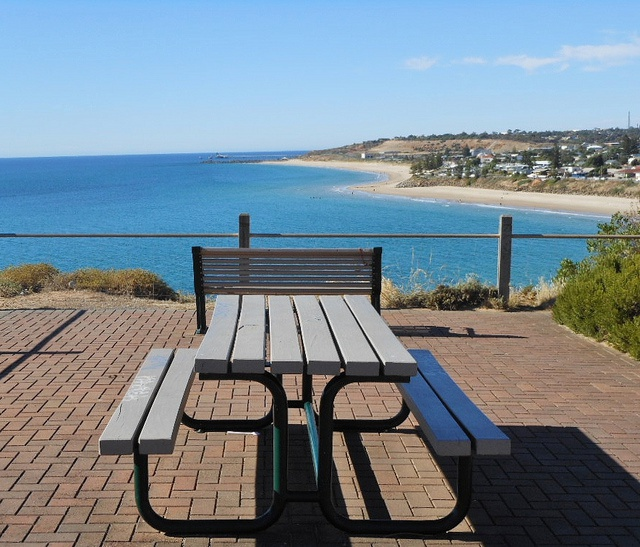Describe the objects in this image and their specific colors. I can see dining table in lightblue, darkgray, black, and gray tones, bench in lightblue, gray, and black tones, bench in lightblue, darkgray, black, gray, and lightgray tones, bench in lightblue, blue, black, and darkblue tones, and boat in lightblue, gray, and darkgray tones in this image. 